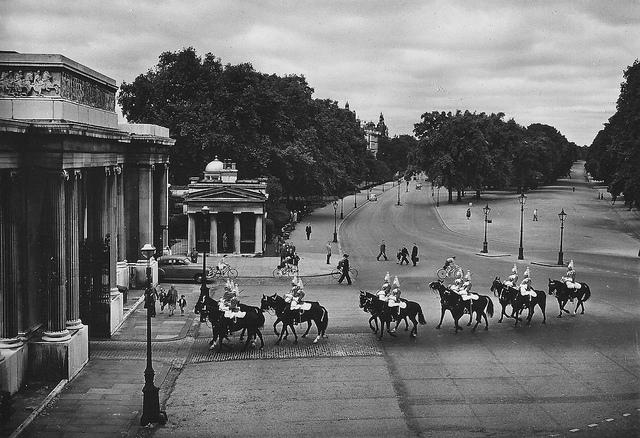What kind of building is it on the left? courthouse 